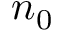<formula> <loc_0><loc_0><loc_500><loc_500>n _ { 0 }</formula> 